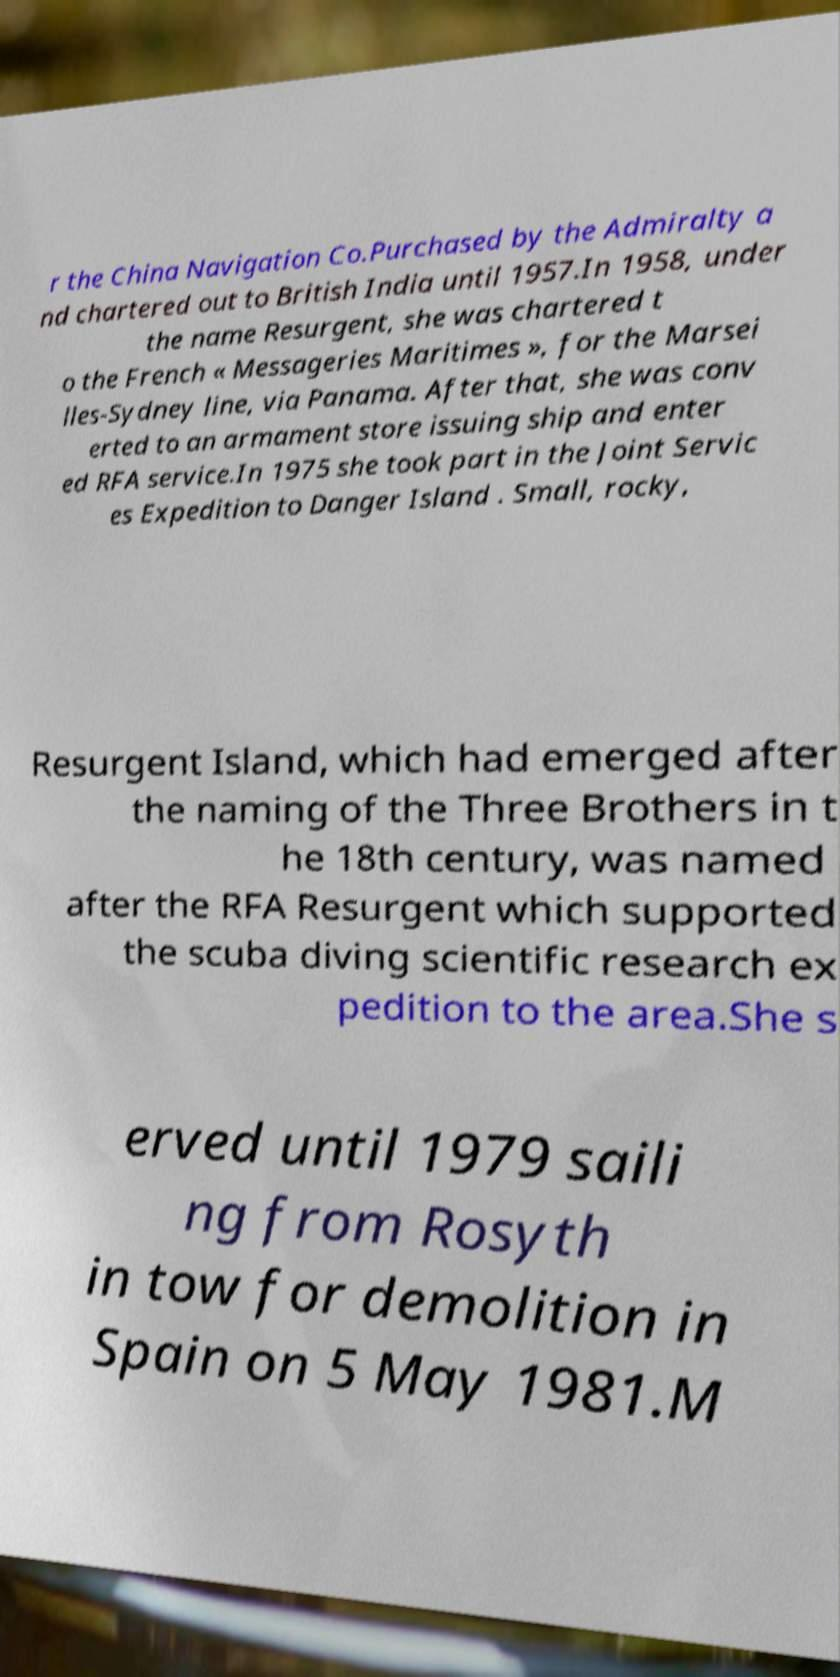Can you read and provide the text displayed in the image?This photo seems to have some interesting text. Can you extract and type it out for me? r the China Navigation Co.Purchased by the Admiralty a nd chartered out to British India until 1957.In 1958, under the name Resurgent, she was chartered t o the French « Messageries Maritimes », for the Marsei lles-Sydney line, via Panama. After that, she was conv erted to an armament store issuing ship and enter ed RFA service.In 1975 she took part in the Joint Servic es Expedition to Danger Island . Small, rocky, Resurgent Island, which had emerged after the naming of the Three Brothers in t he 18th century, was named after the RFA Resurgent which supported the scuba diving scientific research ex pedition to the area.She s erved until 1979 saili ng from Rosyth in tow for demolition in Spain on 5 May 1981.M 